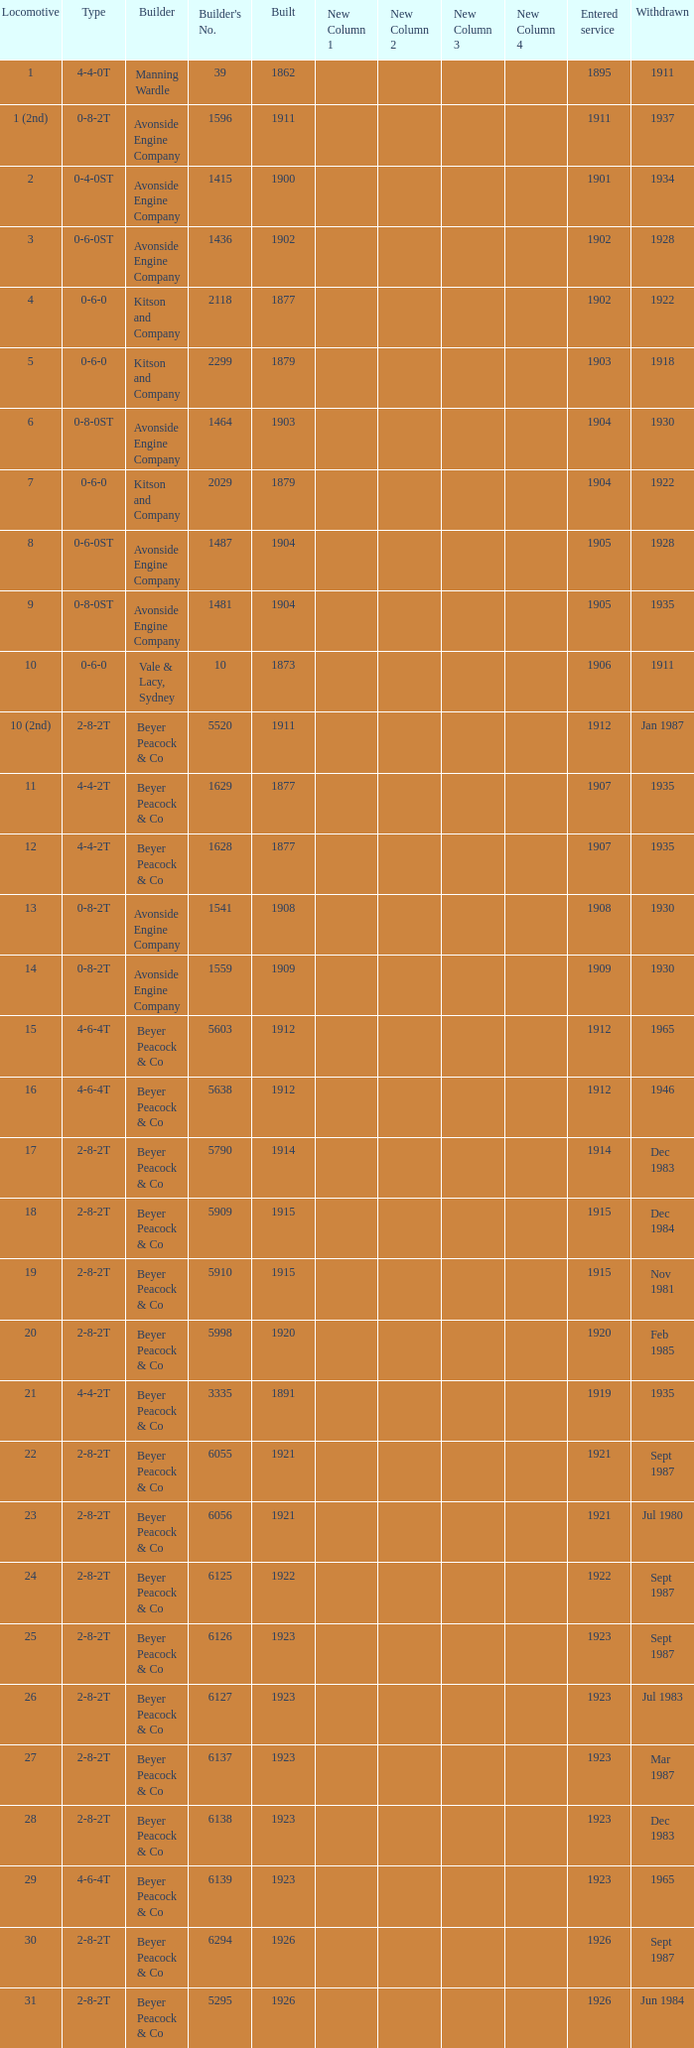How many years entered service when there were 13 locomotives? 1.0. 